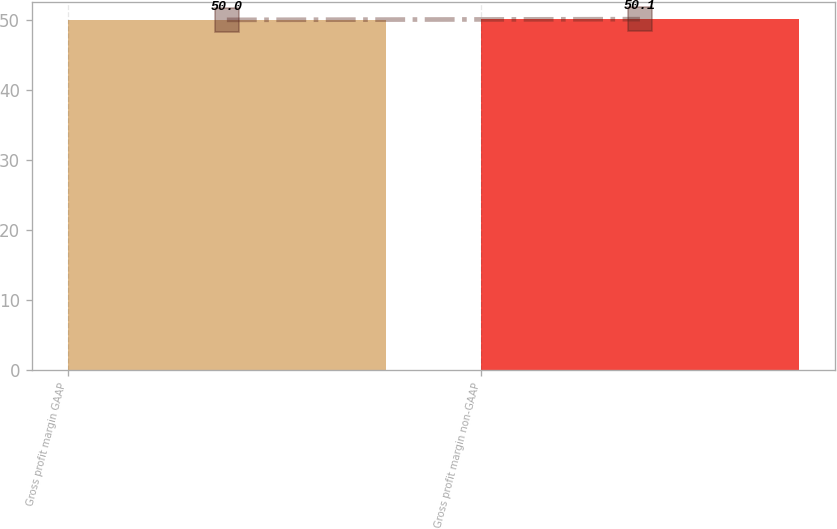Convert chart. <chart><loc_0><loc_0><loc_500><loc_500><bar_chart><fcel>Gross profit margin GAAP<fcel>Gross profit margin non-GAAP<nl><fcel>50<fcel>50.1<nl></chart> 